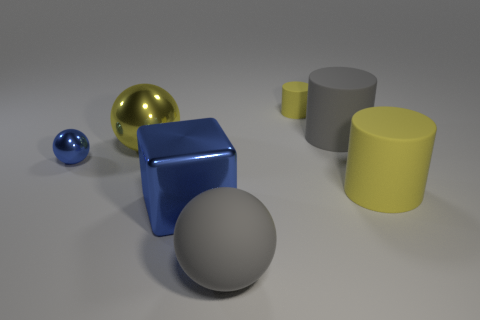Subtract all yellow rubber cylinders. How many cylinders are left? 1 Add 1 blue blocks. How many objects exist? 8 Subtract all yellow balls. How many balls are left? 2 Subtract 3 spheres. How many spheres are left? 0 Subtract all cylinders. How many objects are left? 4 Subtract all green blocks. How many yellow cylinders are left? 2 Add 7 gray balls. How many gray balls are left? 8 Add 6 big blue rubber cubes. How many big blue rubber cubes exist? 6 Subtract 0 cyan blocks. How many objects are left? 7 Subtract all cyan cylinders. Subtract all gray spheres. How many cylinders are left? 3 